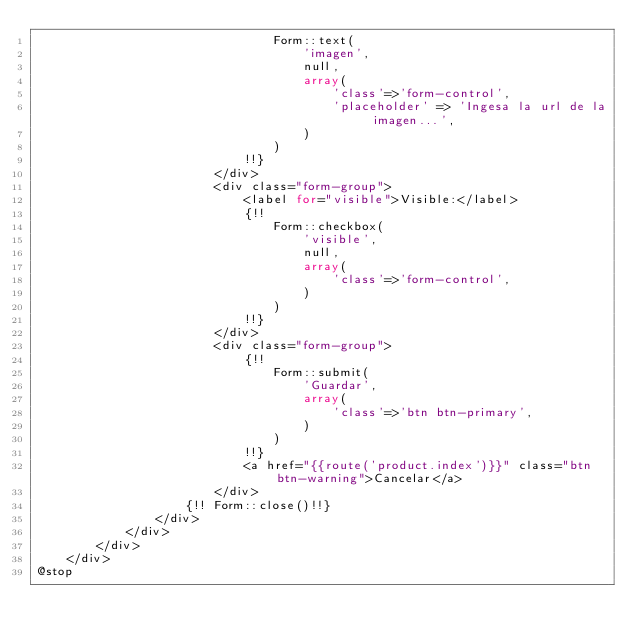<code> <loc_0><loc_0><loc_500><loc_500><_PHP_>								Form::text(
									'imagen',
									null,
									array(
										'class'=>'form-control',
										'placeholder' => 'Ingesa la url de la imagen...',
									)
								)
							!!}
						</div>
						<div class="form-group">
							<label for="visible">Visible:</label>
							{!!
								Form::checkbox(
									'visible',
									null,
									array(
										'class'=>'form-control',
									)
								)
							!!}
						</div>
						<div class="form-group">
							{!!
								Form::submit(
									'Guardar',
									array(
										'class'=>'btn btn-primary',
									)
								)
							!!}
							<a href="{{route('product.index')}}" class="btn btn-warning">Cancelar</a>
						</div>
					{!! Form::close()!!}
				</div>
			</div>
		</div>
	</div>
@stop</code> 